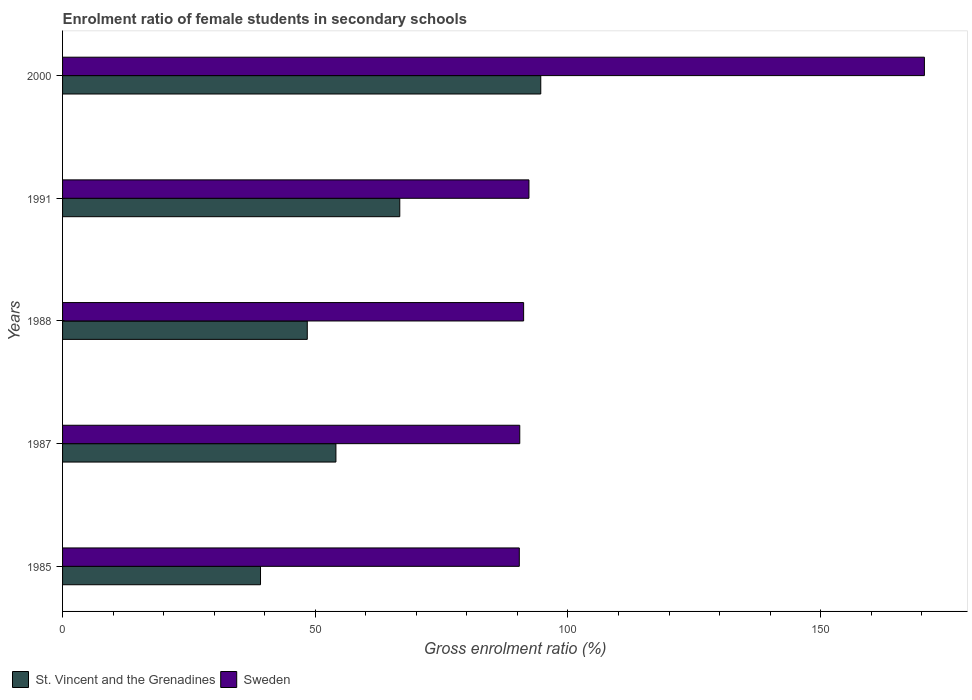How many groups of bars are there?
Offer a terse response. 5. Are the number of bars per tick equal to the number of legend labels?
Your answer should be very brief. Yes. How many bars are there on the 1st tick from the top?
Your answer should be compact. 2. How many bars are there on the 3rd tick from the bottom?
Provide a succinct answer. 2. In how many cases, is the number of bars for a given year not equal to the number of legend labels?
Offer a terse response. 0. What is the enrolment ratio of female students in secondary schools in Sweden in 1987?
Your answer should be compact. 90.47. Across all years, what is the maximum enrolment ratio of female students in secondary schools in St. Vincent and the Grenadines?
Your answer should be compact. 94.62. Across all years, what is the minimum enrolment ratio of female students in secondary schools in St. Vincent and the Grenadines?
Give a very brief answer. 39.17. In which year was the enrolment ratio of female students in secondary schools in St. Vincent and the Grenadines minimum?
Your response must be concise. 1985. What is the total enrolment ratio of female students in secondary schools in St. Vincent and the Grenadines in the graph?
Provide a succinct answer. 303.02. What is the difference between the enrolment ratio of female students in secondary schools in St. Vincent and the Grenadines in 1985 and that in 1991?
Keep it short and to the point. -27.56. What is the difference between the enrolment ratio of female students in secondary schools in St. Vincent and the Grenadines in 1988 and the enrolment ratio of female students in secondary schools in Sweden in 1991?
Offer a very short reply. -43.86. What is the average enrolment ratio of female students in secondary schools in St. Vincent and the Grenadines per year?
Provide a succinct answer. 60.6. In the year 1988, what is the difference between the enrolment ratio of female students in secondary schools in Sweden and enrolment ratio of female students in secondary schools in St. Vincent and the Grenadines?
Provide a short and direct response. 42.81. What is the ratio of the enrolment ratio of female students in secondary schools in St. Vincent and the Grenadines in 1988 to that in 2000?
Provide a short and direct response. 0.51. Is the enrolment ratio of female students in secondary schools in St. Vincent and the Grenadines in 1988 less than that in 2000?
Provide a succinct answer. Yes. What is the difference between the highest and the second highest enrolment ratio of female students in secondary schools in Sweden?
Offer a terse response. 78.25. What is the difference between the highest and the lowest enrolment ratio of female students in secondary schools in St. Vincent and the Grenadines?
Keep it short and to the point. 55.45. In how many years, is the enrolment ratio of female students in secondary schools in St. Vincent and the Grenadines greater than the average enrolment ratio of female students in secondary schools in St. Vincent and the Grenadines taken over all years?
Offer a very short reply. 2. Is the sum of the enrolment ratio of female students in secondary schools in St. Vincent and the Grenadines in 1987 and 1991 greater than the maximum enrolment ratio of female students in secondary schools in Sweden across all years?
Offer a very short reply. No. What does the 1st bar from the top in 1987 represents?
Keep it short and to the point. Sweden. What does the 1st bar from the bottom in 1988 represents?
Offer a terse response. St. Vincent and the Grenadines. How many years are there in the graph?
Ensure brevity in your answer.  5. Where does the legend appear in the graph?
Your answer should be very brief. Bottom left. How many legend labels are there?
Keep it short and to the point. 2. How are the legend labels stacked?
Offer a terse response. Horizontal. What is the title of the graph?
Give a very brief answer. Enrolment ratio of female students in secondary schools. Does "United Arab Emirates" appear as one of the legend labels in the graph?
Ensure brevity in your answer.  No. What is the Gross enrolment ratio (%) in St. Vincent and the Grenadines in 1985?
Your answer should be compact. 39.17. What is the Gross enrolment ratio (%) in Sweden in 1985?
Ensure brevity in your answer.  90.37. What is the Gross enrolment ratio (%) in St. Vincent and the Grenadines in 1987?
Keep it short and to the point. 54.09. What is the Gross enrolment ratio (%) in Sweden in 1987?
Your response must be concise. 90.47. What is the Gross enrolment ratio (%) of St. Vincent and the Grenadines in 1988?
Offer a terse response. 48.42. What is the Gross enrolment ratio (%) in Sweden in 1988?
Provide a short and direct response. 91.23. What is the Gross enrolment ratio (%) of St. Vincent and the Grenadines in 1991?
Provide a succinct answer. 66.72. What is the Gross enrolment ratio (%) in Sweden in 1991?
Keep it short and to the point. 92.28. What is the Gross enrolment ratio (%) of St. Vincent and the Grenadines in 2000?
Give a very brief answer. 94.62. What is the Gross enrolment ratio (%) of Sweden in 2000?
Keep it short and to the point. 170.53. Across all years, what is the maximum Gross enrolment ratio (%) of St. Vincent and the Grenadines?
Give a very brief answer. 94.62. Across all years, what is the maximum Gross enrolment ratio (%) in Sweden?
Offer a terse response. 170.53. Across all years, what is the minimum Gross enrolment ratio (%) in St. Vincent and the Grenadines?
Give a very brief answer. 39.17. Across all years, what is the minimum Gross enrolment ratio (%) in Sweden?
Your answer should be compact. 90.37. What is the total Gross enrolment ratio (%) in St. Vincent and the Grenadines in the graph?
Your answer should be very brief. 303.02. What is the total Gross enrolment ratio (%) of Sweden in the graph?
Offer a terse response. 534.89. What is the difference between the Gross enrolment ratio (%) in St. Vincent and the Grenadines in 1985 and that in 1987?
Provide a short and direct response. -14.92. What is the difference between the Gross enrolment ratio (%) in Sweden in 1985 and that in 1987?
Provide a succinct answer. -0.09. What is the difference between the Gross enrolment ratio (%) in St. Vincent and the Grenadines in 1985 and that in 1988?
Keep it short and to the point. -9.25. What is the difference between the Gross enrolment ratio (%) of Sweden in 1985 and that in 1988?
Keep it short and to the point. -0.86. What is the difference between the Gross enrolment ratio (%) of St. Vincent and the Grenadines in 1985 and that in 1991?
Your response must be concise. -27.56. What is the difference between the Gross enrolment ratio (%) in Sweden in 1985 and that in 1991?
Make the answer very short. -1.91. What is the difference between the Gross enrolment ratio (%) in St. Vincent and the Grenadines in 1985 and that in 2000?
Provide a succinct answer. -55.45. What is the difference between the Gross enrolment ratio (%) in Sweden in 1985 and that in 2000?
Provide a short and direct response. -80.16. What is the difference between the Gross enrolment ratio (%) of St. Vincent and the Grenadines in 1987 and that in 1988?
Offer a terse response. 5.67. What is the difference between the Gross enrolment ratio (%) of Sweden in 1987 and that in 1988?
Your answer should be compact. -0.76. What is the difference between the Gross enrolment ratio (%) in St. Vincent and the Grenadines in 1987 and that in 1991?
Offer a terse response. -12.64. What is the difference between the Gross enrolment ratio (%) in Sweden in 1987 and that in 1991?
Keep it short and to the point. -1.82. What is the difference between the Gross enrolment ratio (%) in St. Vincent and the Grenadines in 1987 and that in 2000?
Ensure brevity in your answer.  -40.53. What is the difference between the Gross enrolment ratio (%) of Sweden in 1987 and that in 2000?
Offer a terse response. -80.06. What is the difference between the Gross enrolment ratio (%) in St. Vincent and the Grenadines in 1988 and that in 1991?
Offer a terse response. -18.3. What is the difference between the Gross enrolment ratio (%) in Sweden in 1988 and that in 1991?
Make the answer very short. -1.05. What is the difference between the Gross enrolment ratio (%) of St. Vincent and the Grenadines in 1988 and that in 2000?
Offer a very short reply. -46.2. What is the difference between the Gross enrolment ratio (%) in Sweden in 1988 and that in 2000?
Give a very brief answer. -79.3. What is the difference between the Gross enrolment ratio (%) of St. Vincent and the Grenadines in 1991 and that in 2000?
Your response must be concise. -27.9. What is the difference between the Gross enrolment ratio (%) of Sweden in 1991 and that in 2000?
Make the answer very short. -78.25. What is the difference between the Gross enrolment ratio (%) of St. Vincent and the Grenadines in 1985 and the Gross enrolment ratio (%) of Sweden in 1987?
Your response must be concise. -51.3. What is the difference between the Gross enrolment ratio (%) of St. Vincent and the Grenadines in 1985 and the Gross enrolment ratio (%) of Sweden in 1988?
Make the answer very short. -52.06. What is the difference between the Gross enrolment ratio (%) of St. Vincent and the Grenadines in 1985 and the Gross enrolment ratio (%) of Sweden in 1991?
Your answer should be very brief. -53.12. What is the difference between the Gross enrolment ratio (%) in St. Vincent and the Grenadines in 1985 and the Gross enrolment ratio (%) in Sweden in 2000?
Give a very brief answer. -131.36. What is the difference between the Gross enrolment ratio (%) of St. Vincent and the Grenadines in 1987 and the Gross enrolment ratio (%) of Sweden in 1988?
Give a very brief answer. -37.14. What is the difference between the Gross enrolment ratio (%) in St. Vincent and the Grenadines in 1987 and the Gross enrolment ratio (%) in Sweden in 1991?
Keep it short and to the point. -38.2. What is the difference between the Gross enrolment ratio (%) of St. Vincent and the Grenadines in 1987 and the Gross enrolment ratio (%) of Sweden in 2000?
Offer a terse response. -116.44. What is the difference between the Gross enrolment ratio (%) of St. Vincent and the Grenadines in 1988 and the Gross enrolment ratio (%) of Sweden in 1991?
Provide a short and direct response. -43.86. What is the difference between the Gross enrolment ratio (%) of St. Vincent and the Grenadines in 1988 and the Gross enrolment ratio (%) of Sweden in 2000?
Ensure brevity in your answer.  -122.11. What is the difference between the Gross enrolment ratio (%) of St. Vincent and the Grenadines in 1991 and the Gross enrolment ratio (%) of Sweden in 2000?
Provide a succinct answer. -103.81. What is the average Gross enrolment ratio (%) in St. Vincent and the Grenadines per year?
Give a very brief answer. 60.6. What is the average Gross enrolment ratio (%) of Sweden per year?
Make the answer very short. 106.98. In the year 1985, what is the difference between the Gross enrolment ratio (%) of St. Vincent and the Grenadines and Gross enrolment ratio (%) of Sweden?
Your response must be concise. -51.21. In the year 1987, what is the difference between the Gross enrolment ratio (%) of St. Vincent and the Grenadines and Gross enrolment ratio (%) of Sweden?
Your answer should be compact. -36.38. In the year 1988, what is the difference between the Gross enrolment ratio (%) of St. Vincent and the Grenadines and Gross enrolment ratio (%) of Sweden?
Provide a succinct answer. -42.81. In the year 1991, what is the difference between the Gross enrolment ratio (%) in St. Vincent and the Grenadines and Gross enrolment ratio (%) in Sweden?
Offer a very short reply. -25.56. In the year 2000, what is the difference between the Gross enrolment ratio (%) of St. Vincent and the Grenadines and Gross enrolment ratio (%) of Sweden?
Provide a succinct answer. -75.91. What is the ratio of the Gross enrolment ratio (%) in St. Vincent and the Grenadines in 1985 to that in 1987?
Make the answer very short. 0.72. What is the ratio of the Gross enrolment ratio (%) of St. Vincent and the Grenadines in 1985 to that in 1988?
Your answer should be compact. 0.81. What is the ratio of the Gross enrolment ratio (%) in Sweden in 1985 to that in 1988?
Your response must be concise. 0.99. What is the ratio of the Gross enrolment ratio (%) in St. Vincent and the Grenadines in 1985 to that in 1991?
Ensure brevity in your answer.  0.59. What is the ratio of the Gross enrolment ratio (%) in Sweden in 1985 to that in 1991?
Your response must be concise. 0.98. What is the ratio of the Gross enrolment ratio (%) in St. Vincent and the Grenadines in 1985 to that in 2000?
Give a very brief answer. 0.41. What is the ratio of the Gross enrolment ratio (%) of Sweden in 1985 to that in 2000?
Your answer should be very brief. 0.53. What is the ratio of the Gross enrolment ratio (%) in St. Vincent and the Grenadines in 1987 to that in 1988?
Offer a very short reply. 1.12. What is the ratio of the Gross enrolment ratio (%) of St. Vincent and the Grenadines in 1987 to that in 1991?
Your response must be concise. 0.81. What is the ratio of the Gross enrolment ratio (%) in Sweden in 1987 to that in 1991?
Your answer should be very brief. 0.98. What is the ratio of the Gross enrolment ratio (%) of St. Vincent and the Grenadines in 1987 to that in 2000?
Offer a terse response. 0.57. What is the ratio of the Gross enrolment ratio (%) of Sweden in 1987 to that in 2000?
Offer a very short reply. 0.53. What is the ratio of the Gross enrolment ratio (%) in St. Vincent and the Grenadines in 1988 to that in 1991?
Offer a terse response. 0.73. What is the ratio of the Gross enrolment ratio (%) in St. Vincent and the Grenadines in 1988 to that in 2000?
Keep it short and to the point. 0.51. What is the ratio of the Gross enrolment ratio (%) of Sweden in 1988 to that in 2000?
Your response must be concise. 0.54. What is the ratio of the Gross enrolment ratio (%) of St. Vincent and the Grenadines in 1991 to that in 2000?
Your response must be concise. 0.71. What is the ratio of the Gross enrolment ratio (%) of Sweden in 1991 to that in 2000?
Your answer should be very brief. 0.54. What is the difference between the highest and the second highest Gross enrolment ratio (%) of St. Vincent and the Grenadines?
Your response must be concise. 27.9. What is the difference between the highest and the second highest Gross enrolment ratio (%) in Sweden?
Give a very brief answer. 78.25. What is the difference between the highest and the lowest Gross enrolment ratio (%) of St. Vincent and the Grenadines?
Your answer should be very brief. 55.45. What is the difference between the highest and the lowest Gross enrolment ratio (%) of Sweden?
Offer a very short reply. 80.16. 